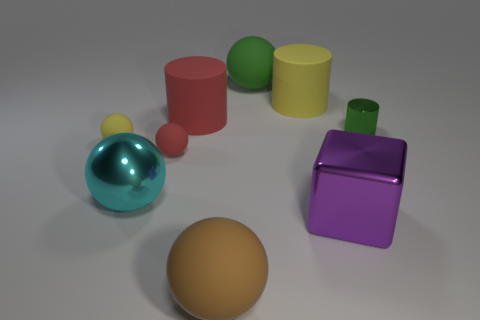What materials are the objects in the image made of? The objects in the image seem to be made of a plastic or matte finish material, displaying various solid colors and a soft sheen. 